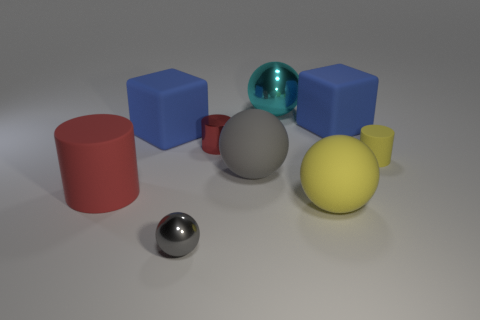Is there a big red object of the same shape as the gray metallic object?
Give a very brief answer. No. What number of matte things are to the right of the ball behind the large blue rubber cube that is on the left side of the red metal cylinder?
Make the answer very short. 3. Is the color of the small rubber cylinder the same as the small metallic thing behind the large red rubber object?
Your answer should be very brief. No. How many objects are gray balls that are behind the big red matte cylinder or metallic things in front of the big yellow rubber thing?
Make the answer very short. 2. Are there more red metallic objects in front of the tiny shiny cylinder than yellow matte balls that are in front of the gray metal thing?
Ensure brevity in your answer.  No. What material is the cube on the left side of the blue rubber object on the right side of the blue block left of the cyan thing?
Make the answer very short. Rubber. Does the tiny shiny object in front of the big matte cylinder have the same shape as the gray object that is behind the red rubber cylinder?
Ensure brevity in your answer.  Yes. Is there another rubber cylinder of the same size as the yellow cylinder?
Provide a succinct answer. No. How many gray objects are either metallic cylinders or tiny balls?
Make the answer very short. 1. How many big rubber spheres have the same color as the large metal ball?
Give a very brief answer. 0. 